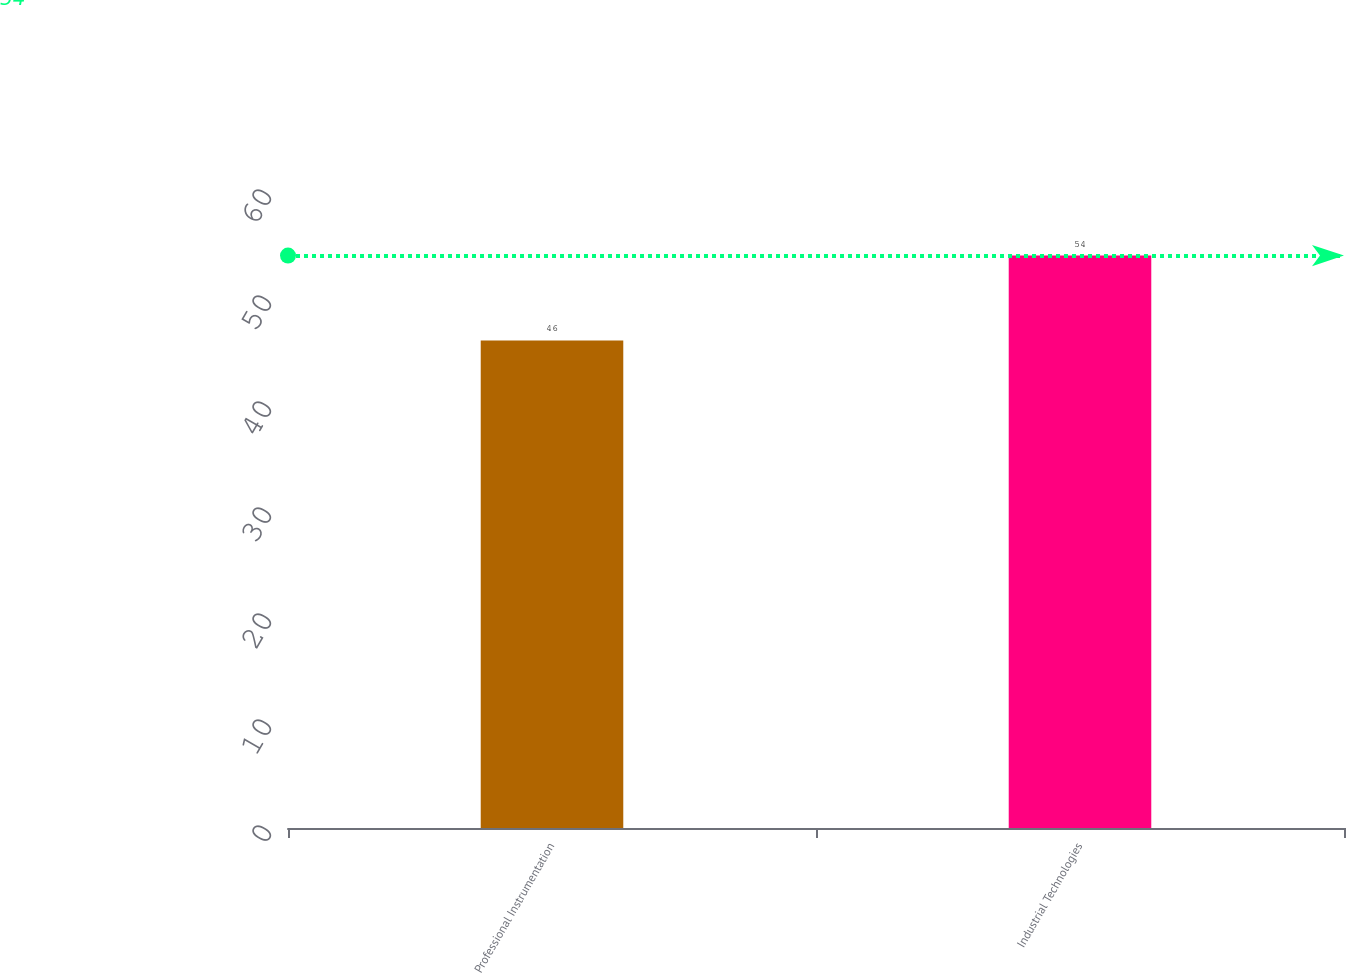Convert chart to OTSL. <chart><loc_0><loc_0><loc_500><loc_500><bar_chart><fcel>Professional Instrumentation<fcel>Industrial Technologies<nl><fcel>46<fcel>54<nl></chart> 